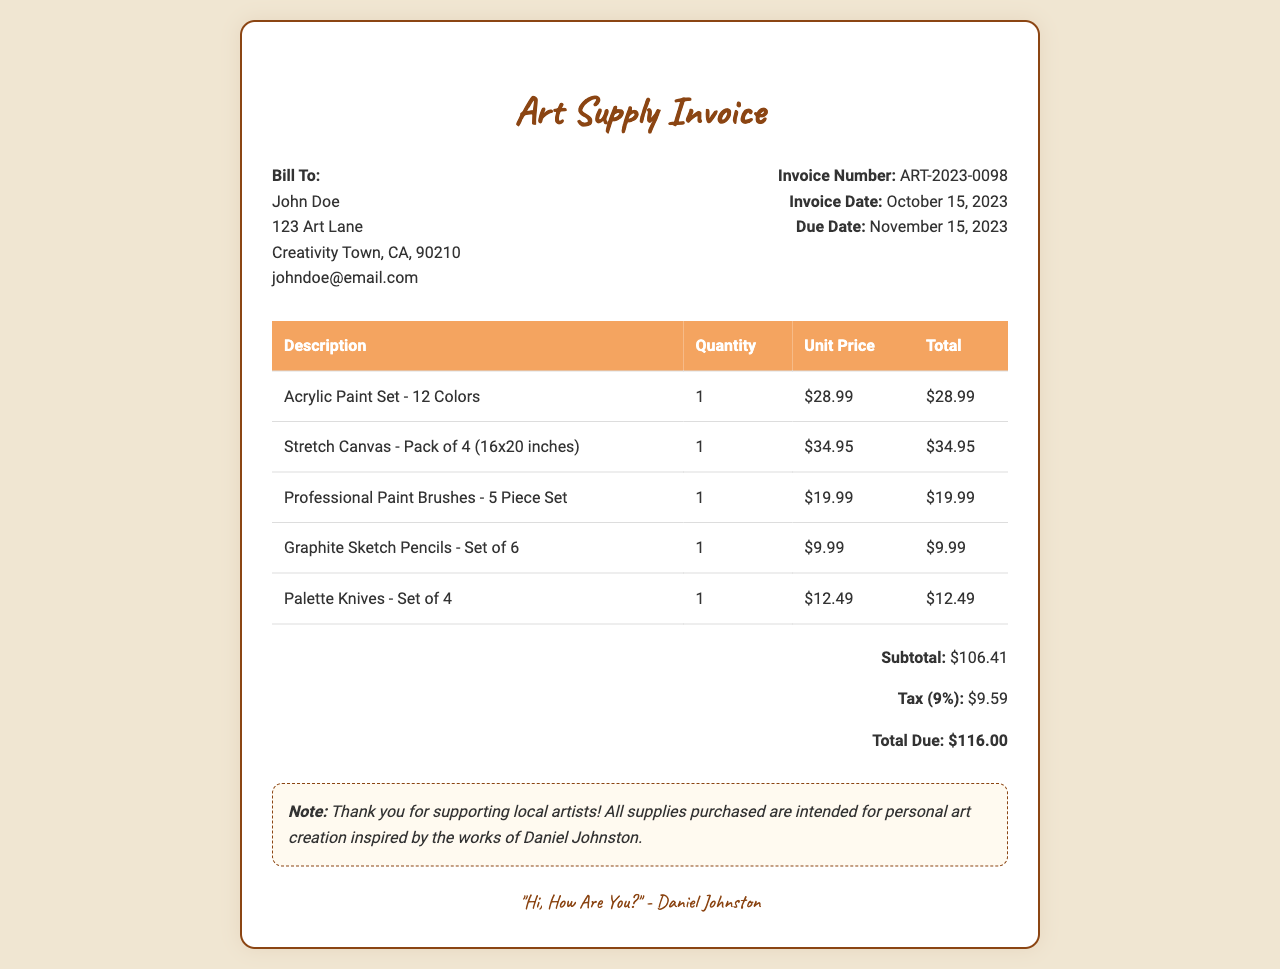What is the invoice number? The invoice number is mentioned in the invoice details section.
Answer: ART-2023-0098 What is the due date for payment? The due date is listed in the invoice details section.
Answer: November 15, 2023 How many colors are in the acrylic paint set? The description of the acrylic paint set states it includes 12 colors.
Answer: 12 Colors What is the total amount due? The total amount is calculated and displayed in the total section of the invoice.
Answer: $116.00 What is the tax rate applied? The tax amount is listed, and based on the subtotal, it corresponds to a 9% tax rate.
Answer: 9% How many items are listed in the invoice? The total number of items can be counted from the description rows in the table.
Answer: 5 Items What is the subtotal before tax? The subtotal is clearly stated in the total section of the invoice.
Answer: $106.41 Who is the bill recipient? The bill recipient's information is found at the top of the document under "Bill To."
Answer: John Doe What is the date of the invoice? The invoice date is listed in the invoice details section.
Answer: October 15, 2023 